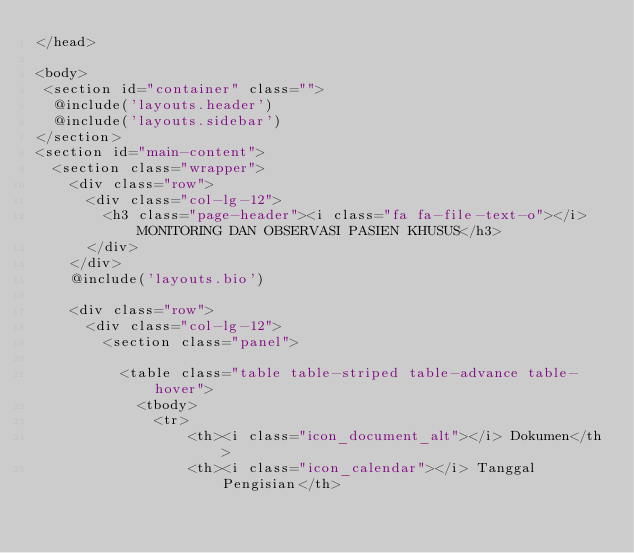Convert code to text. <code><loc_0><loc_0><loc_500><loc_500><_PHP_></head>

<body>
 <section id="container" class="">
  @include('layouts.header')
  @include('layouts.sidebar')
</section>
<section id="main-content">
  <section class="wrapper">
    <div class="row">
      <div class="col-lg-12">
        <h3 class="page-header"><i class="fa fa-file-text-o"></i> MONITORING DAN OBSERVASI PASIEN KHUSUS</h3>
      </div>
    </div>
    @include('layouts.bio')

    <div class="row">
      <div class="col-lg-12">
        <section class="panel">

          <table class="table table-striped table-advance table-hover">
            <tbody>
              <tr>
                  <th><i class="icon_document_alt"></i> Dokumen</th>
                  <th><i class="icon_calendar"></i> Tanggal Pengisian</th></code> 